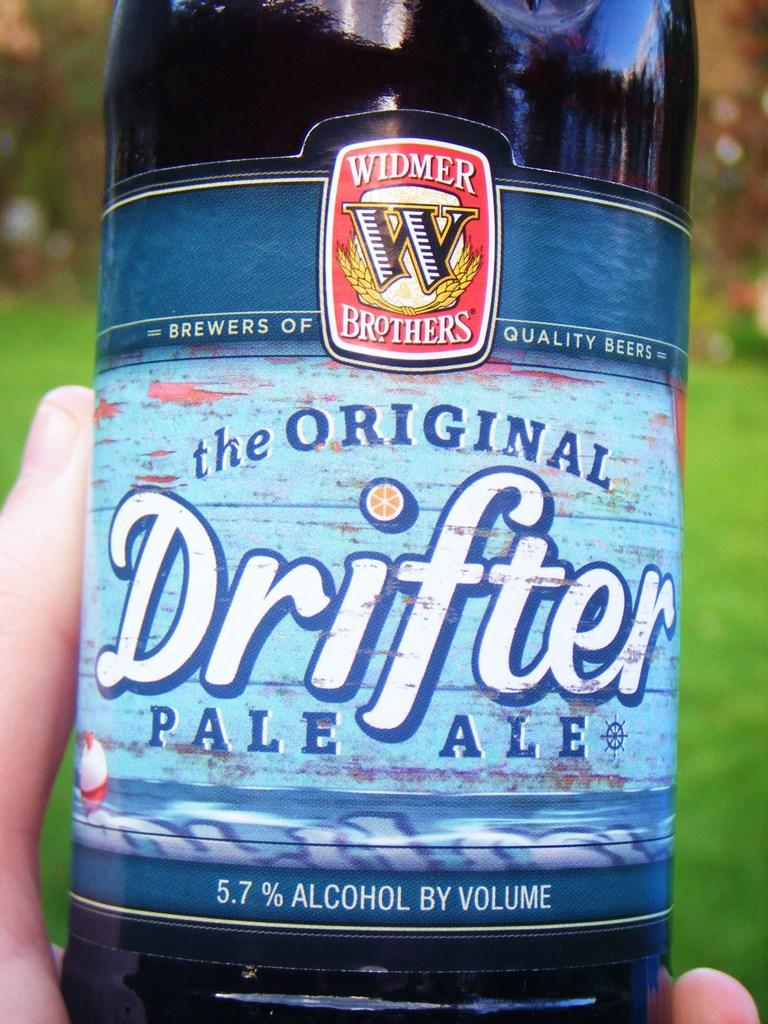<image>
Summarize the visual content of the image. The original drifer pale ale is in somebody hand 